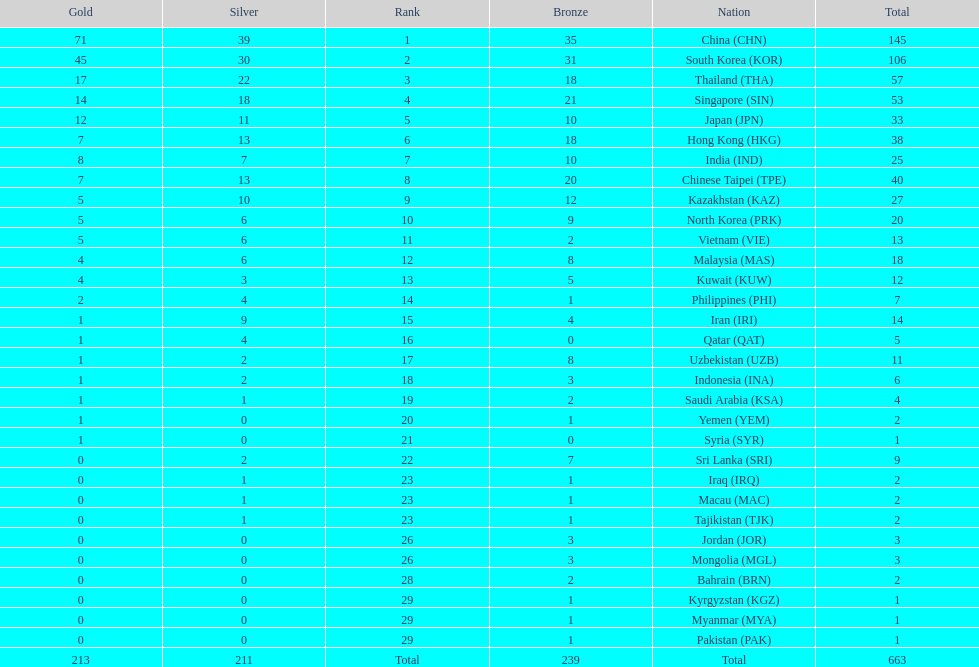What is the total number of medals that india won in the asian youth games? 25. 